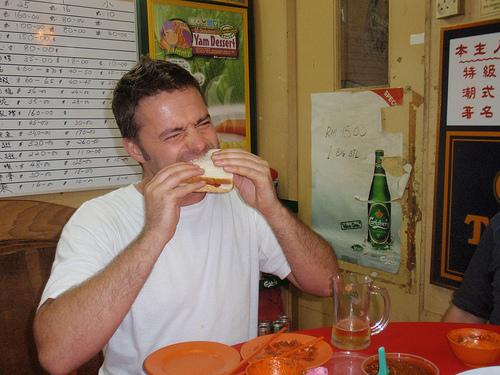Describe the setting of the image, focusing on the surroundings. The image showcases a dining area with a bright red table, orange plates and bowls, a glass mug of beer, and several intriguing wall decorations including a yam dessert advertisement and a whiteboard menu. Detail the scene focusing on the table and its contents. A red tablecloth covers a table set with two orange plates, a glass mug of beer, and an orange bowl, presenting an appetizing and vibrant dining scene. Summarize the image, focusing on the colors and the man's activities. The image displays a mix of vibrant colors, with a man in a white shirt eating a sandwich at a red table, orange eating implements, and colorful wall decor. Write a brief description of the featured person, including their appearance and actions. The man, sporting short brown hair and a white t-shirt, is making a comical face while happily munching on a sandwich. Explain the man's actions and expressions in the photo. The man, clad in a white shirt, is eating a sandwich with a humorous expression on his face, seemingly enjoying his meal and the atmosphere. Provide a snapshot of a particular moment in the image, mentioning the man and an element from the table. The man, clad in a white shirt, is caught mid-bite of his sandwich, balancing the mostly empty glass mug of beer on the table as he enjoys his meal. Describe the variety of wall decorations in the image, without mentioning the man. The walls are adorned with a torn sign advertising beer, a foreign writing, a whiteboard menu behind diners, and an ad for yam dessert, creating an eclectic ambiance. Mention the key aspects of the image related to the person featured. A man with short brown hair, wearing a white tee shirt, is making a funny face while enjoying a white bread sandwich and sitting at a table with a red tablecloth. Provide a brief overview of the scene in the picture. A man in a white t-shirt is eating a sandwich at a red table with orange dishes, while surrounded by various advertisements and signs on the wall. Illustrate the scene by mentioning the man, the table, and the surrounding decorations. A man wearing a white tee shirt is dining on a sandwich at a red table with orange dishes, while various signs and advertisements create an engaging backdrop. 